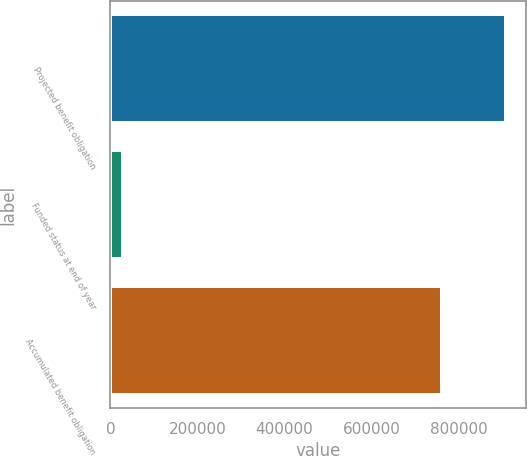Convert chart to OTSL. <chart><loc_0><loc_0><loc_500><loc_500><bar_chart><fcel>Projected benefit obligation<fcel>Funded status at end of year<fcel>Accumulated benefit obligation<nl><fcel>908167<fcel>28956<fcel>761802<nl></chart> 